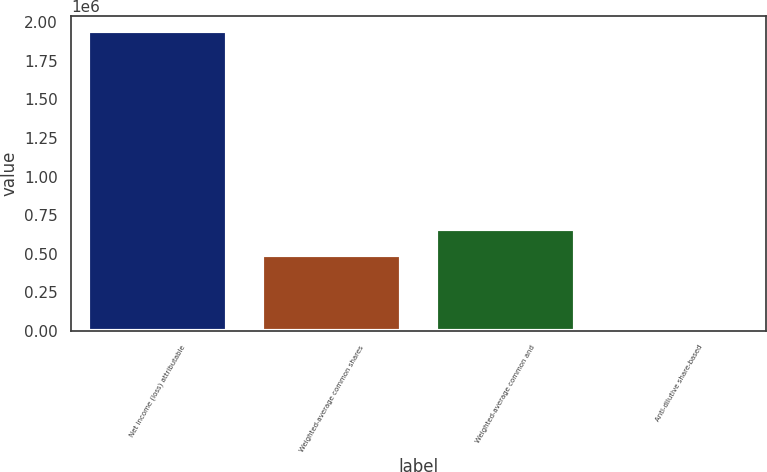<chart> <loc_0><loc_0><loc_500><loc_500><bar_chart><fcel>Net income (loss) attributable<fcel>Weighted-average common shares<fcel>Weighted-average common and<fcel>Anti-dilutive share-based<nl><fcel>1.94196e+06<fcel>488988<fcel>663253<fcel>25041<nl></chart> 